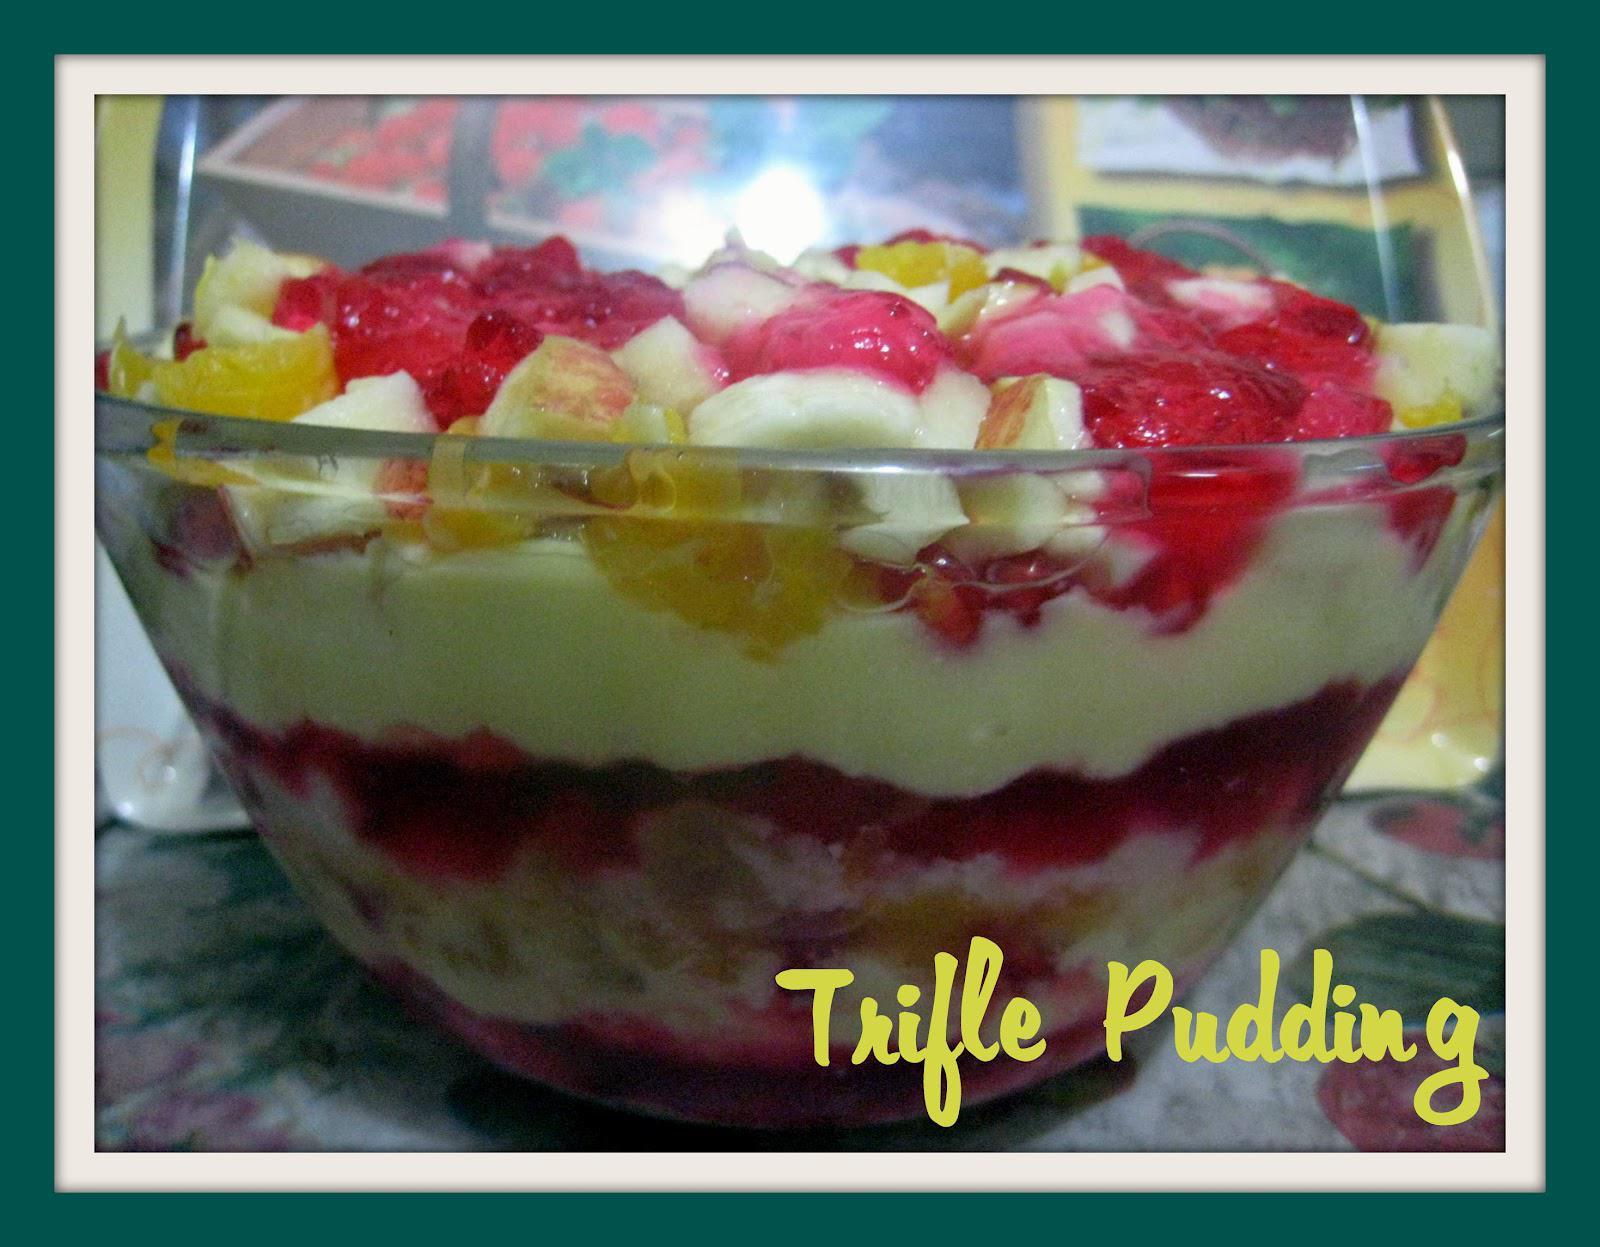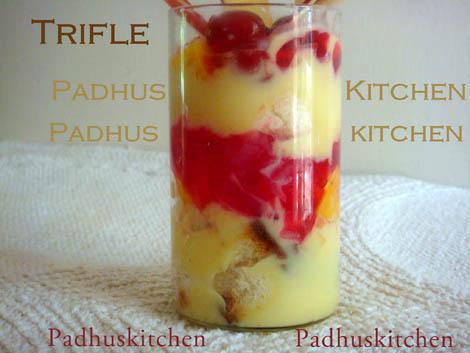The first image is the image on the left, the second image is the image on the right. Evaluate the accuracy of this statement regarding the images: "There are spoons resting next to a cup of trifle.". Is it true? Answer yes or no. No. 